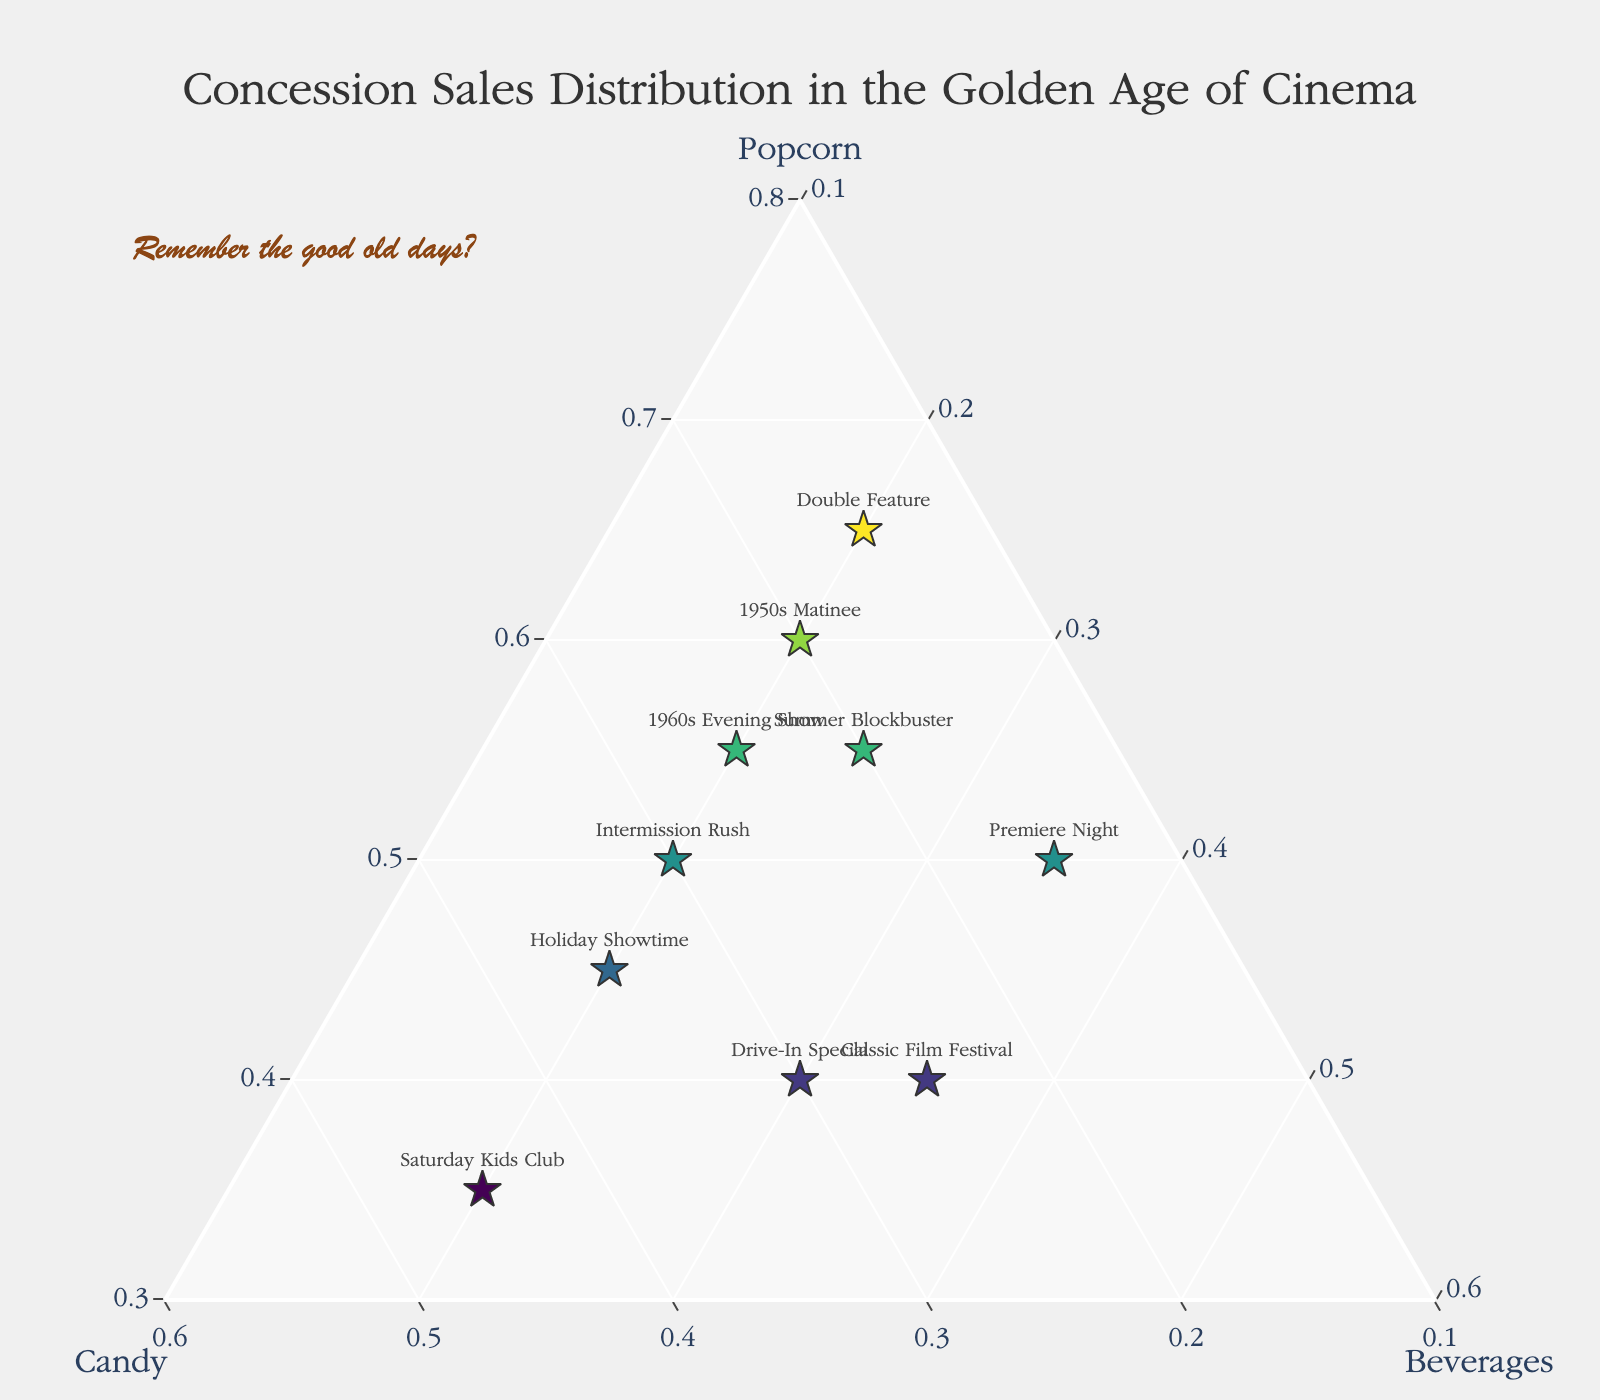How many data points are there in the figure? By counting the number of labeled points on the ternary plot, which corresponds to the different concessions events listed (e.g., 1950s Matinee, 1960s Evening Show, etc.), we can determine the total number of data points.
Answer: 10 Which concession has the highest percentage of popcorn sales? By looking at the "Popcorn" axis, find the data point that is farthest along this axis. The data point labeled "Double Feature" is the highest at 0.65.
Answer: Double Feature What is the average percentage of candy sales across all concessions? Calculate the sum of all the percentages of candy sales from each concession and then divide by the number of data points. The sum is 0.20 + 0.25 + 0.30 + 0.45 + 0.15 + 0.15 + 0.35 + 0.20 + 0.25 + 0.30 = 2.60. Divide by 10 (the number of data points) to get the average.
Answer: 0.26 Which concession has the equal distribution of candy and beverages? Look for the point on the ternary plot where the candy and beverage axes are at the same value. The point labeled "Drive-In Special" shows 0.30 for both candy and beverages.
Answer: Drive-In Special How does the percentage of beverage sales for "Premiere Night" compare to "Saturday Kids Club"? Locate the points on the chart for both "Premiere Night" and "Saturday Kids Club" and compare their positions along the beverage axis. "Premiere Night" has a higher percentage of beverage sales at 0.35 compared to "Saturday Kids Club"'s 0.20.
Answer: Premiere Night has higher beverage sales Which concession has the closest balance between popcorn, candy, and beverages? Look for the point that is centrally located in the triangle, indicating a more balanced distribution across all three categories. "Drive-In Special" with 0.40, 0.30, and 0.30 is the closest balanced.
Answer: Drive-In Special What is the difference in popcorn sales percentages between "1950s Matinee" and "1960s Evening Show"? Subtract the percentage of popcorn sales for "1960s Evening Show" (0.55) from that of "1950s Matinee" (0.60). The difference is 0.60 - 0.55.
Answer: 0.05 Which event has the highest percentage of candy sales and what is it? By checking the candy axis on the ternary plot, "Saturday Kids Club" has the highest candy sales at 0.45.
Answer: Saturday Kids Club Which concession event has the lowest percentage of beverage sales? Check the points along the beverage axis to find the lowest value. Both "1950s Matinee", "1960s Evening Show", "Double Feature", "Holiday Showtime", "Intermission Rush", and "Saturday Kids Club" share this low value of 0.20.
Answer: Multiple events (0.20) Are there any events where popcorn and candy sales are equal? Locate points on the ternary plot where the positions on the popcorn and candy axes are equal. None of the events have exactly equal popcorn and candy sales based on the given data.
Answer: No 